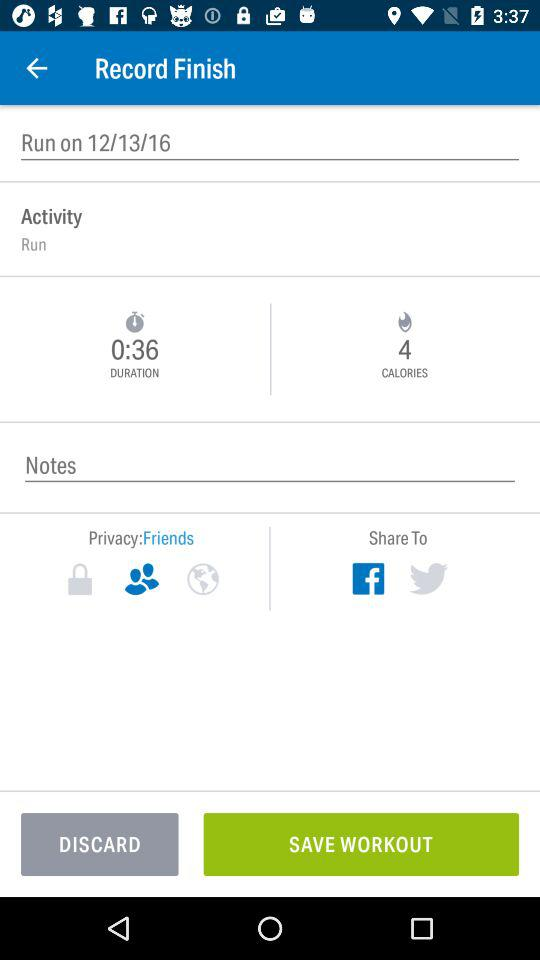How many calories are burned? There are 4 calories burned. 